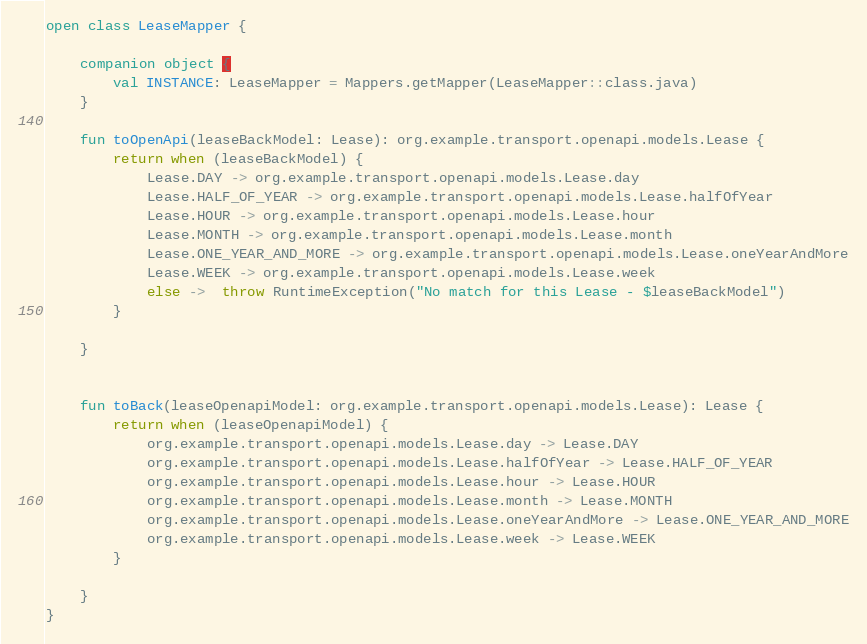Convert code to text. <code><loc_0><loc_0><loc_500><loc_500><_Kotlin_>open class LeaseMapper {

    companion object {
        val INSTANCE: LeaseMapper = Mappers.getMapper(LeaseMapper::class.java)
    }

    fun toOpenApi(leaseBackModel: Lease): org.example.transport.openapi.models.Lease {
        return when (leaseBackModel) {
            Lease.DAY -> org.example.transport.openapi.models.Lease.day
            Lease.HALF_OF_YEAR -> org.example.transport.openapi.models.Lease.halfOfYear
            Lease.HOUR -> org.example.transport.openapi.models.Lease.hour
            Lease.MONTH -> org.example.transport.openapi.models.Lease.month
            Lease.ONE_YEAR_AND_MORE -> org.example.transport.openapi.models.Lease.oneYearAndMore
            Lease.WEEK -> org.example.transport.openapi.models.Lease.week
            else ->  throw RuntimeException("No match for this Lease - $leaseBackModel")
        }

    }


    fun toBack(leaseOpenapiModel: org.example.transport.openapi.models.Lease): Lease {
        return when (leaseOpenapiModel) {
            org.example.transport.openapi.models.Lease.day -> Lease.DAY
            org.example.transport.openapi.models.Lease.halfOfYear -> Lease.HALF_OF_YEAR
            org.example.transport.openapi.models.Lease.hour -> Lease.HOUR
            org.example.transport.openapi.models.Lease.month -> Lease.MONTH
            org.example.transport.openapi.models.Lease.oneYearAndMore -> Lease.ONE_YEAR_AND_MORE
            org.example.transport.openapi.models.Lease.week -> Lease.WEEK
        }

    }
}</code> 